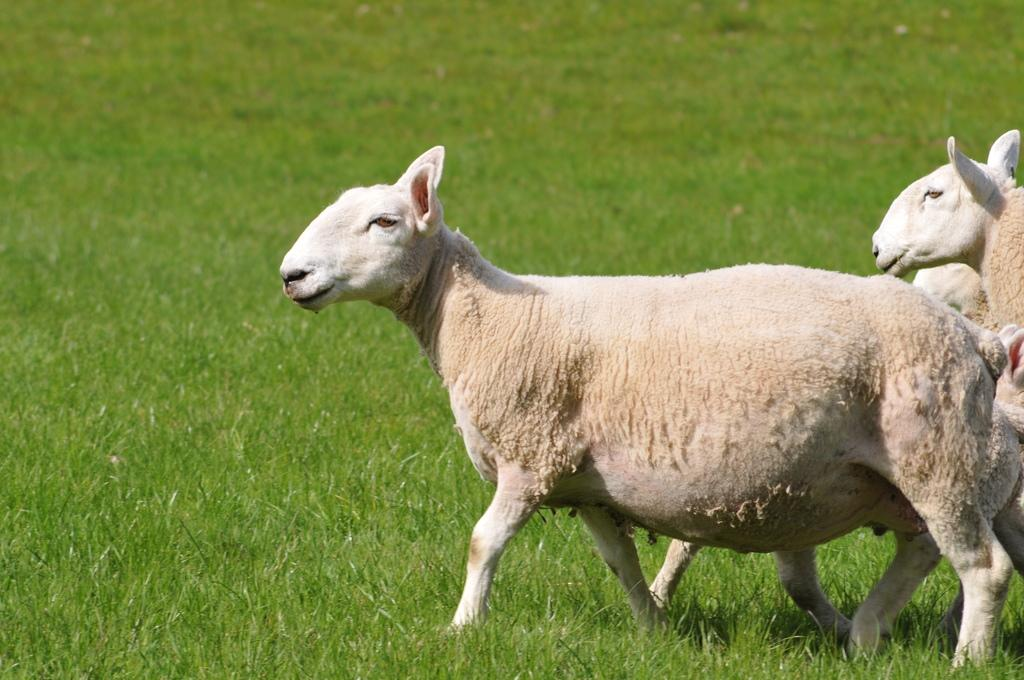What type of animals are in the image? There are sheep in the image. Where are the sheep located? The sheep are on the grass. What advice does the sheep's grandmother give in the image? There is no grandmother or advice present in the image; it features sheep on the grass. What account number is associated with the sheep in the image? There is no account number associated with the sheep in the image; it is a photograph of sheep on the grass. 